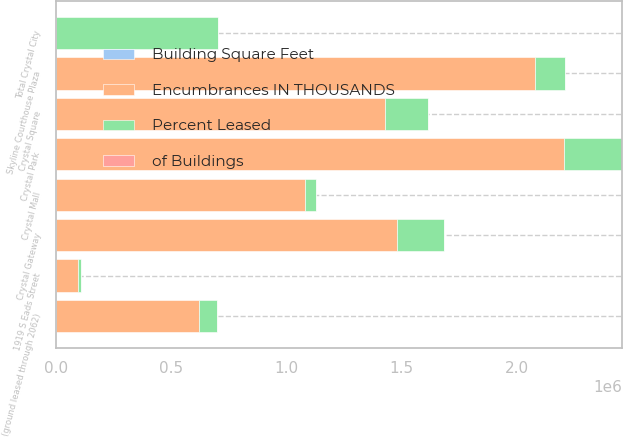Convert chart. <chart><loc_0><loc_0><loc_500><loc_500><stacked_bar_chart><ecel><fcel>Crystal Park<fcel>Crystal Gateway<fcel>Crystal Square<fcel>Crystal Mall<fcel>1919 S Eads Street<fcel>Total Crystal City<fcel>Skyline Courthouse Plaza<fcel>(ground leased through 2062)<nl><fcel>of Buildings<fcel>5<fcel>5<fcel>4<fcel>4<fcel>1<fcel>28<fcel>7<fcel>2<nl><fcel>Encumbrances IN THOUSANDS<fcel>2.206e+06<fcel>1.478e+06<fcel>1.426e+06<fcel>1.08e+06<fcel>96000<fcel>100<fcel>2.08e+06<fcel>622000<nl><fcel>Building Square Feet<fcel>67.3<fcel>94.6<fcel>96<fcel>100<fcel>57.4<fcel>86.4<fcel>94.7<fcel>97.9<nl><fcel>Percent Leased<fcel>249212<fcel>203889<fcel>188633<fcel>49214<fcel>11757<fcel>702705<fcel>128732<fcel>75971<nl></chart> 